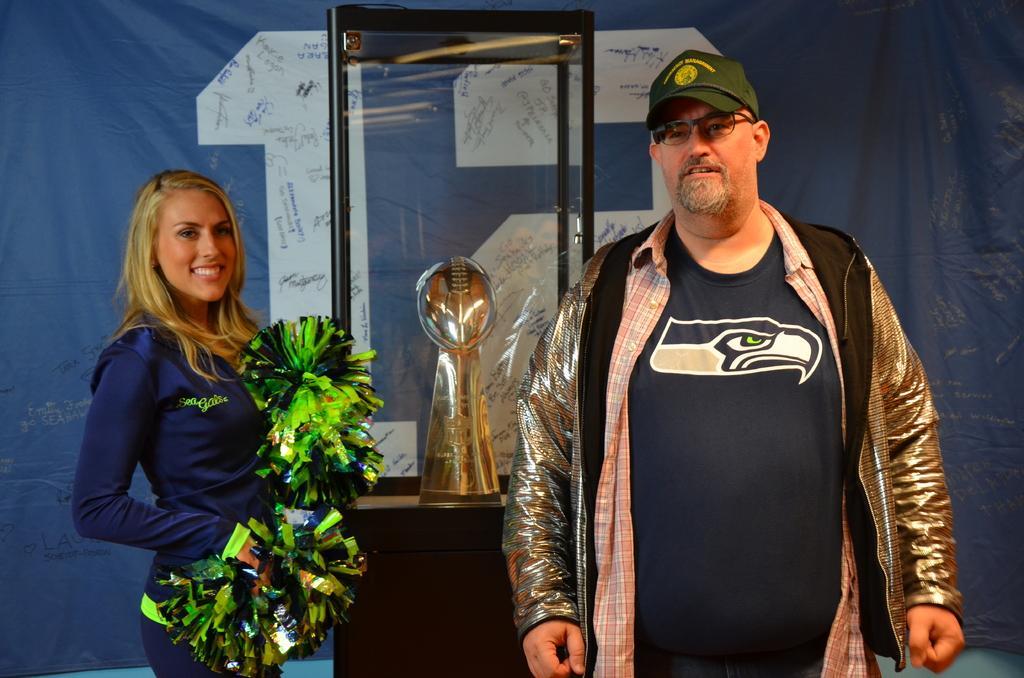Can you describe this image briefly? In this picture I can see a woman and a man, they are standing in the middle. In the background I can see a glass box and a banner. 